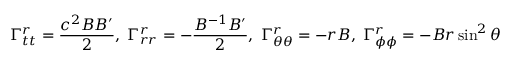Convert formula to latex. <formula><loc_0><loc_0><loc_500><loc_500>\Gamma _ { t t } ^ { r } = { \frac { c ^ { 2 } B B ^ { \prime } } { 2 } } , \, \Gamma _ { r r } ^ { r } = - { \frac { B ^ { - 1 } B ^ { \prime } } { 2 } } , \, \Gamma _ { \theta \theta } ^ { r } = - r B , \, \Gamma _ { \phi \phi } ^ { r } = - B r \sin ^ { 2 } \theta</formula> 